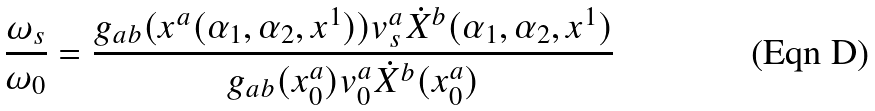<formula> <loc_0><loc_0><loc_500><loc_500>\frac { \omega _ { s } } { \omega _ { 0 } } = \frac { g _ { a b } ( x ^ { a } ( \alpha _ { 1 } , \alpha _ { 2 } , x ^ { 1 } ) ) v _ { s } ^ { a } \dot { X } ^ { b } ( \alpha _ { 1 } , \alpha _ { 2 } , x ^ { 1 } ) } { g _ { a b } ( x _ { 0 } ^ { a } ) v _ { 0 } ^ { a } \dot { X } ^ { b } ( x _ { 0 } ^ { a } ) }</formula> 